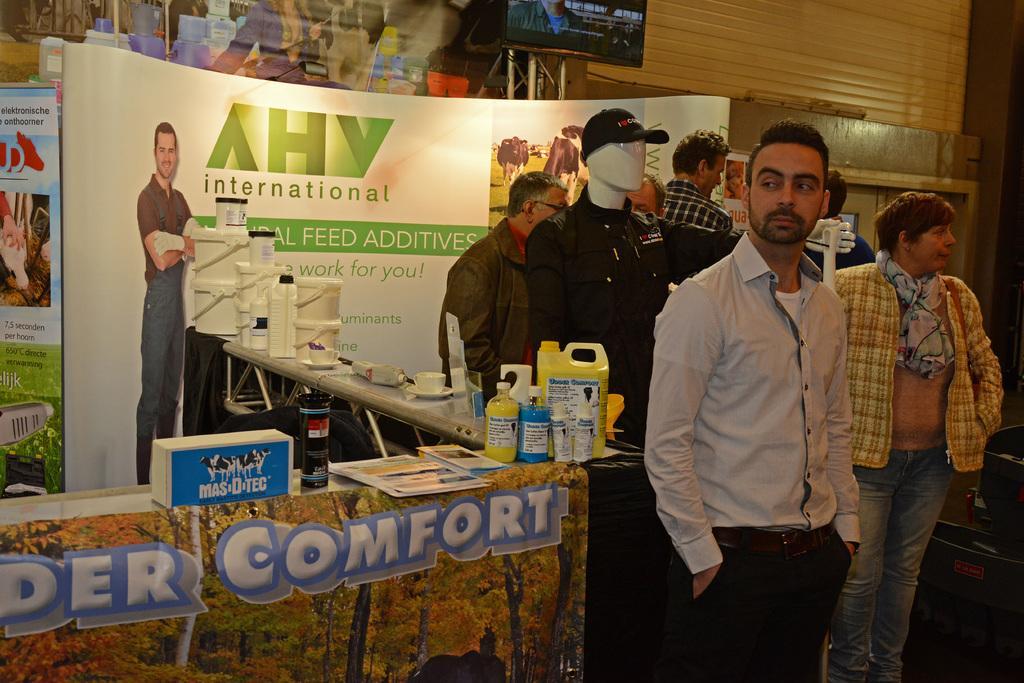In one or two sentences, can you explain what this image depicts? On the right side, there are persons and statues. Beside them, there is a table on which, there are bottles and other objects. Beside this table, there is another table which is covered with a banner. On this table, there are a box, bottles and brochures. In the background, there is a hoarding, there is a screen and there is a wall. 